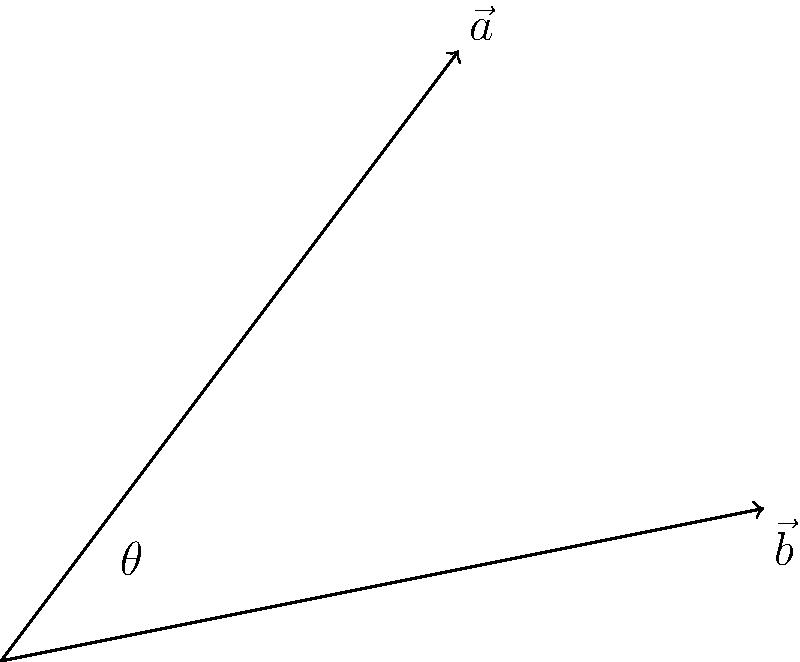Given two vectors $\vec{a} = 3\hat{i} + 4\hat{j}$ and $\vec{b} = 5\hat{i} + \hat{j}$, find the angle $\theta$ between them using the dot product formula. Round your answer to the nearest degree. To find the angle between two vectors using the dot product formula, we'll follow these steps:

1) The dot product formula states: $\vec{a} \cdot \vec{b} = |\vec{a}||\vec{b}|\cos\theta$

2) Calculate the dot product of $\vec{a}$ and $\vec{b}$:
   $\vec{a} \cdot \vec{b} = (3)(5) + (4)(1) = 15 + 4 = 19$

3) Calculate the magnitudes of $\vec{a}$ and $\vec{b}$:
   $|\vec{a}| = \sqrt{3^2 + 4^2} = \sqrt{9 + 16} = \sqrt{25} = 5$
   $|\vec{b}| = \sqrt{5^2 + 1^2} = \sqrt{25 + 1} = \sqrt{26}$

4) Substitute into the dot product formula:
   $19 = 5\sqrt{26}\cos\theta$

5) Solve for $\theta$:
   $\cos\theta = \frac{19}{5\sqrt{26}}$
   $\theta = \arccos(\frac{19}{5\sqrt{26}})$

6) Calculate and round to the nearest degree:
   $\theta \approx 22.6°$, which rounds to 23°
Answer: 23° 